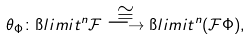Convert formula to latex. <formula><loc_0><loc_0><loc_500><loc_500>\theta _ { \Phi } \colon \i l i m i t ^ { n } \mathcal { F } \overset { \cong } { \longrightarrow } \i l i m i t ^ { n } ( \mathcal { F } \Phi ) ,</formula> 